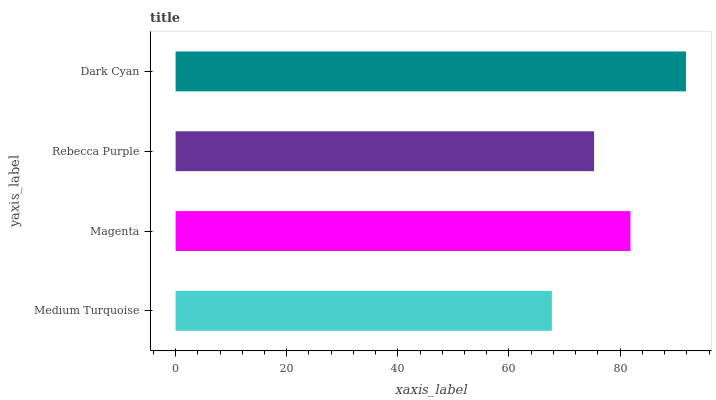Is Medium Turquoise the minimum?
Answer yes or no. Yes. Is Dark Cyan the maximum?
Answer yes or no. Yes. Is Magenta the minimum?
Answer yes or no. No. Is Magenta the maximum?
Answer yes or no. No. Is Magenta greater than Medium Turquoise?
Answer yes or no. Yes. Is Medium Turquoise less than Magenta?
Answer yes or no. Yes. Is Medium Turquoise greater than Magenta?
Answer yes or no. No. Is Magenta less than Medium Turquoise?
Answer yes or no. No. Is Magenta the high median?
Answer yes or no. Yes. Is Rebecca Purple the low median?
Answer yes or no. Yes. Is Rebecca Purple the high median?
Answer yes or no. No. Is Magenta the low median?
Answer yes or no. No. 